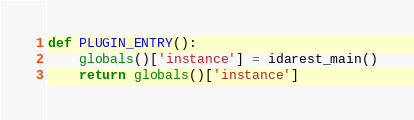<code> <loc_0><loc_0><loc_500><loc_500><_Python_>
def PLUGIN_ENTRY():
    globals()['instance'] = idarest_main()
    return globals()['instance']
</code> 